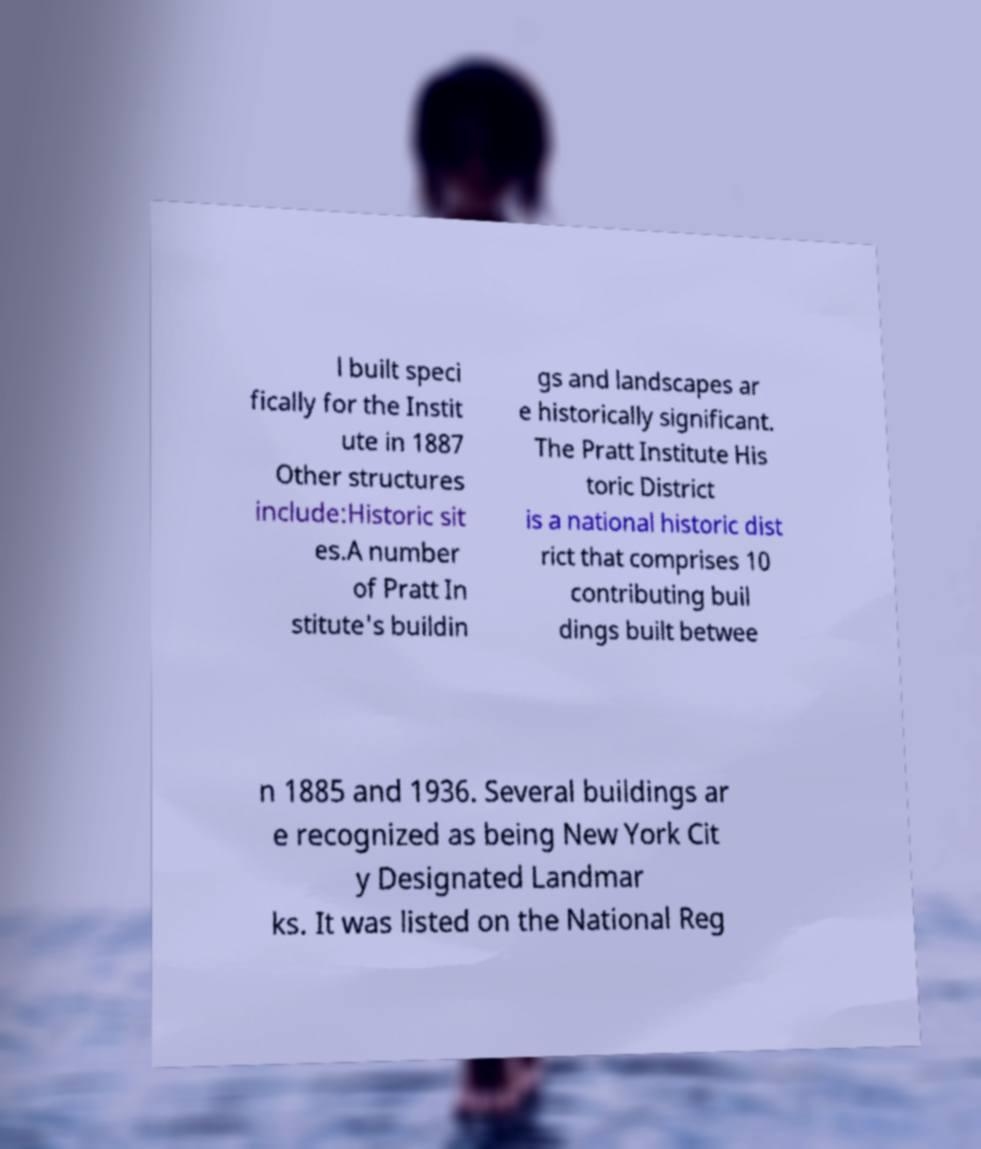Can you read and provide the text displayed in the image?This photo seems to have some interesting text. Can you extract and type it out for me? l built speci fically for the Instit ute in 1887 Other structures include:Historic sit es.A number of Pratt In stitute's buildin gs and landscapes ar e historically significant. The Pratt Institute His toric District is a national historic dist rict that comprises 10 contributing buil dings built betwee n 1885 and 1936. Several buildings ar e recognized as being New York Cit y Designated Landmar ks. It was listed on the National Reg 